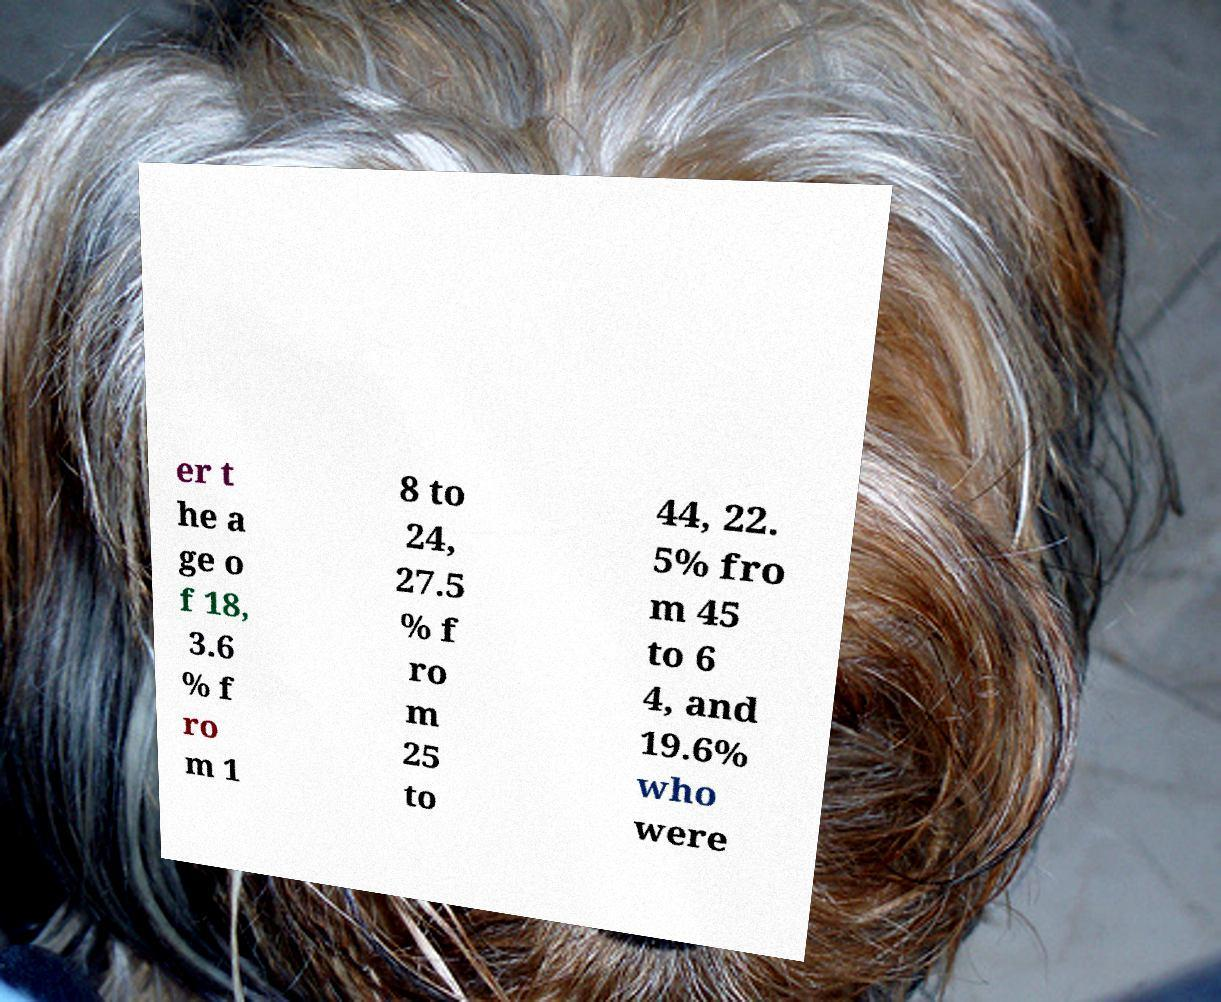Could you extract and type out the text from this image? er t he a ge o f 18, 3.6 % f ro m 1 8 to 24, 27.5 % f ro m 25 to 44, 22. 5% fro m 45 to 6 4, and 19.6% who were 